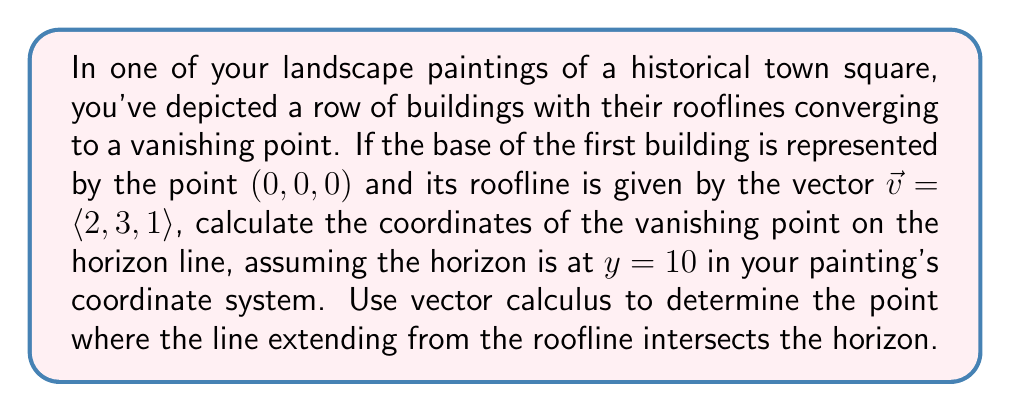What is the answer to this math problem? To solve this problem, we'll use vector calculus and parametric equations. Let's approach this step-by-step:

1) The line representing the roofline can be described by the parametric equation:
   $$\vec{r}(t) = \langle 0, 0, 0 \rangle + t\langle 2, 3, 1 \rangle$$
   where $t$ is a scalar parameter.

2) We can write this as three separate equations:
   $$x = 2t$$
   $$y = 3t$$
   $$z = t$$

3) We know that the horizon line is at $y = 10$ in our painting's coordinate system. To find where our line intersects this horizon, we set $y = 10$:

   $$10 = 3t$$

4) Solving for $t$:
   $$t = \frac{10}{3}$$

5) Now that we know the value of $t$ at the intersection point, we can substitute this back into our equations for $x$ and $z$:

   $$x = 2(\frac{10}{3}) = \frac{20}{3}$$
   $$z = \frac{10}{3}$$

6) The $y$-coordinate is already known to be 10.

Therefore, the vanishing point has coordinates $(\frac{20}{3}, 10, \frac{10}{3})$.
Answer: The coordinates of the vanishing point are $(\frac{20}{3}, 10, \frac{10}{3})$. 